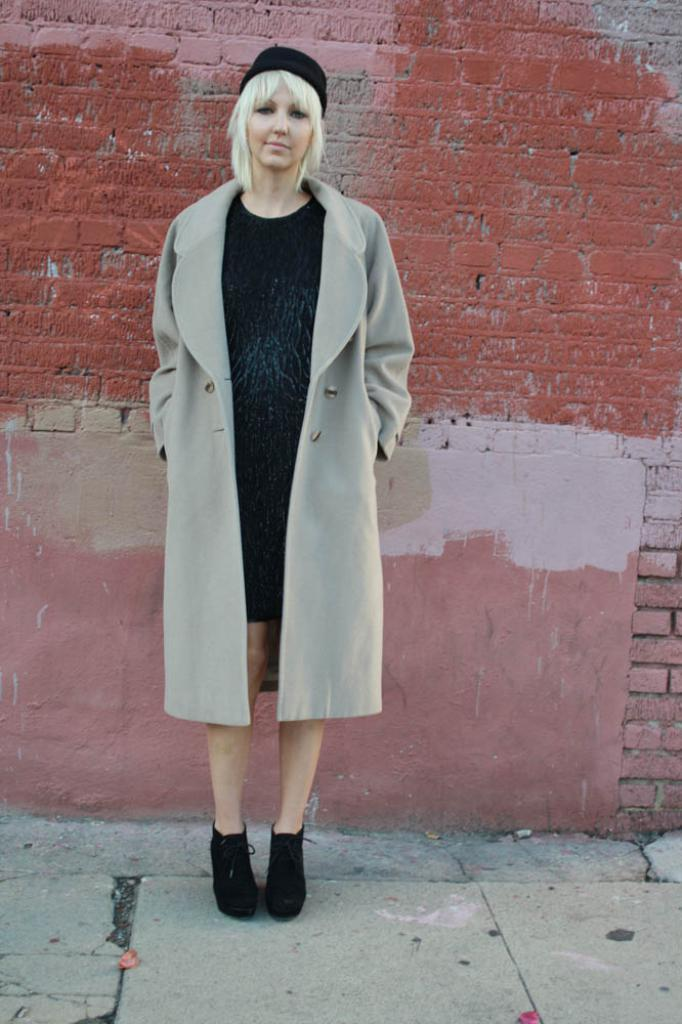Who is the main subject in the image? There is a lady standing in the center of the image. What is the lady wearing? The lady is wearing a coat. What can be seen in the background of the image? There is a wall in the background of the image. Where is the mailbox located in the image? There is no mailbox present in the image. Is there a volcano visible in the background of the image? There is no volcano present in the image; only a wall is visible in the background. 